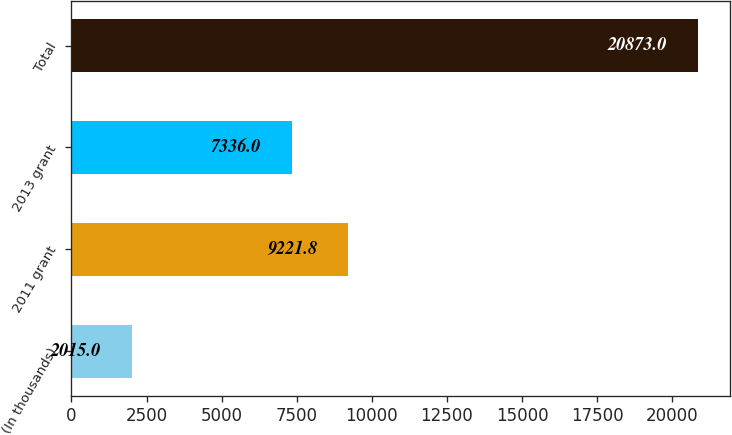Convert chart. <chart><loc_0><loc_0><loc_500><loc_500><bar_chart><fcel>(In thousands)<fcel>2011 grant<fcel>2013 grant<fcel>Total<nl><fcel>2015<fcel>9221.8<fcel>7336<fcel>20873<nl></chart> 